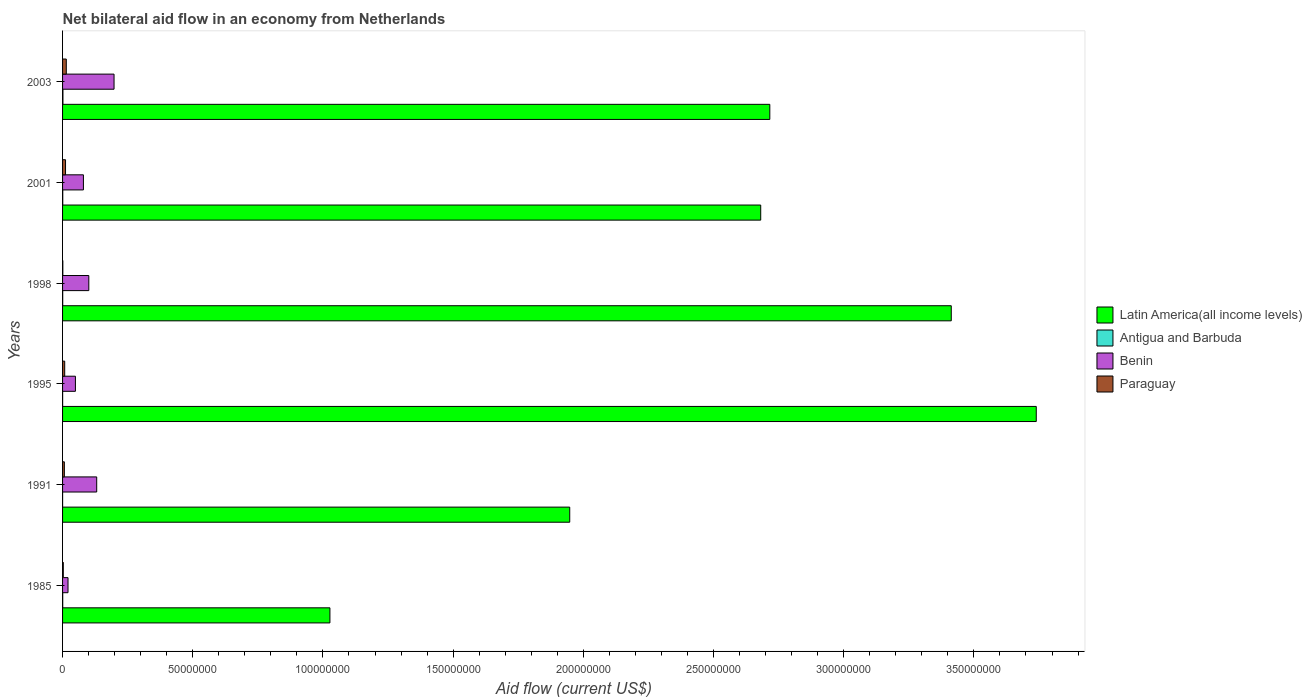How many groups of bars are there?
Offer a terse response. 6. In how many cases, is the number of bars for a given year not equal to the number of legend labels?
Provide a succinct answer. 0. What is the net bilateral aid flow in Antigua and Barbuda in 1991?
Your response must be concise. 10000. Across all years, what is the maximum net bilateral aid flow in Paraguay?
Offer a terse response. 1.43e+06. Across all years, what is the minimum net bilateral aid flow in Paraguay?
Make the answer very short. 1.00e+05. In which year was the net bilateral aid flow in Paraguay maximum?
Provide a succinct answer. 2003. What is the total net bilateral aid flow in Paraguay in the graph?
Ensure brevity in your answer.  4.46e+06. What is the difference between the net bilateral aid flow in Antigua and Barbuda in 1991 and that in 1998?
Provide a succinct answer. -4.00e+04. What is the difference between the net bilateral aid flow in Antigua and Barbuda in 1995 and the net bilateral aid flow in Latin America(all income levels) in 2001?
Keep it short and to the point. -2.68e+08. What is the average net bilateral aid flow in Paraguay per year?
Make the answer very short. 7.43e+05. In the year 2001, what is the difference between the net bilateral aid flow in Paraguay and net bilateral aid flow in Latin America(all income levels)?
Keep it short and to the point. -2.67e+08. In how many years, is the net bilateral aid flow in Paraguay greater than 70000000 US$?
Give a very brief answer. 0. What is the ratio of the net bilateral aid flow in Paraguay in 1995 to that in 2003?
Your answer should be compact. 0.57. What is the difference between the highest and the lowest net bilateral aid flow in Benin?
Your response must be concise. 1.77e+07. In how many years, is the net bilateral aid flow in Antigua and Barbuda greater than the average net bilateral aid flow in Antigua and Barbuda taken over all years?
Offer a very short reply. 3. What does the 4th bar from the top in 1998 represents?
Provide a short and direct response. Latin America(all income levels). What does the 3rd bar from the bottom in 1998 represents?
Provide a succinct answer. Benin. Is it the case that in every year, the sum of the net bilateral aid flow in Benin and net bilateral aid flow in Latin America(all income levels) is greater than the net bilateral aid flow in Paraguay?
Provide a succinct answer. Yes. Are all the bars in the graph horizontal?
Your response must be concise. Yes. How many years are there in the graph?
Provide a succinct answer. 6. Does the graph contain any zero values?
Make the answer very short. No. Does the graph contain grids?
Offer a very short reply. No. Where does the legend appear in the graph?
Your response must be concise. Center right. How many legend labels are there?
Ensure brevity in your answer.  4. How are the legend labels stacked?
Provide a short and direct response. Vertical. What is the title of the graph?
Your response must be concise. Net bilateral aid flow in an economy from Netherlands. Does "Antigua and Barbuda" appear as one of the legend labels in the graph?
Provide a short and direct response. Yes. What is the label or title of the X-axis?
Make the answer very short. Aid flow (current US$). What is the Aid flow (current US$) in Latin America(all income levels) in 1985?
Give a very brief answer. 1.03e+08. What is the Aid flow (current US$) of Benin in 1985?
Keep it short and to the point. 2.09e+06. What is the Aid flow (current US$) of Paraguay in 1985?
Your answer should be compact. 2.80e+05. What is the Aid flow (current US$) in Latin America(all income levels) in 1991?
Your answer should be compact. 1.95e+08. What is the Aid flow (current US$) of Antigua and Barbuda in 1991?
Offer a very short reply. 10000. What is the Aid flow (current US$) in Benin in 1991?
Ensure brevity in your answer.  1.31e+07. What is the Aid flow (current US$) of Paraguay in 1991?
Provide a short and direct response. 6.90e+05. What is the Aid flow (current US$) of Latin America(all income levels) in 1995?
Make the answer very short. 3.74e+08. What is the Aid flow (current US$) in Benin in 1995?
Make the answer very short. 4.94e+06. What is the Aid flow (current US$) in Paraguay in 1995?
Your answer should be compact. 8.20e+05. What is the Aid flow (current US$) of Latin America(all income levels) in 1998?
Make the answer very short. 3.41e+08. What is the Aid flow (current US$) in Benin in 1998?
Make the answer very short. 1.01e+07. What is the Aid flow (current US$) of Paraguay in 1998?
Give a very brief answer. 1.00e+05. What is the Aid flow (current US$) of Latin America(all income levels) in 2001?
Provide a short and direct response. 2.68e+08. What is the Aid flow (current US$) of Antigua and Barbuda in 2001?
Make the answer very short. 7.00e+04. What is the Aid flow (current US$) in Benin in 2001?
Offer a terse response. 8.01e+06. What is the Aid flow (current US$) in Paraguay in 2001?
Make the answer very short. 1.14e+06. What is the Aid flow (current US$) in Latin America(all income levels) in 2003?
Provide a succinct answer. 2.72e+08. What is the Aid flow (current US$) of Antigua and Barbuda in 2003?
Offer a terse response. 1.40e+05. What is the Aid flow (current US$) of Benin in 2003?
Offer a terse response. 1.98e+07. What is the Aid flow (current US$) of Paraguay in 2003?
Offer a terse response. 1.43e+06. Across all years, what is the maximum Aid flow (current US$) of Latin America(all income levels)?
Offer a very short reply. 3.74e+08. Across all years, what is the maximum Aid flow (current US$) of Benin?
Ensure brevity in your answer.  1.98e+07. Across all years, what is the maximum Aid flow (current US$) in Paraguay?
Provide a short and direct response. 1.43e+06. Across all years, what is the minimum Aid flow (current US$) of Latin America(all income levels)?
Offer a terse response. 1.03e+08. Across all years, what is the minimum Aid flow (current US$) in Antigua and Barbuda?
Provide a short and direct response. 10000. Across all years, what is the minimum Aid flow (current US$) in Benin?
Offer a very short reply. 2.09e+06. Across all years, what is the minimum Aid flow (current US$) in Paraguay?
Your answer should be compact. 1.00e+05. What is the total Aid flow (current US$) in Latin America(all income levels) in the graph?
Offer a very short reply. 1.55e+09. What is the total Aid flow (current US$) in Benin in the graph?
Give a very brief answer. 5.80e+07. What is the total Aid flow (current US$) in Paraguay in the graph?
Provide a short and direct response. 4.46e+06. What is the difference between the Aid flow (current US$) of Latin America(all income levels) in 1985 and that in 1991?
Provide a succinct answer. -9.21e+07. What is the difference between the Aid flow (current US$) in Benin in 1985 and that in 1991?
Provide a succinct answer. -1.10e+07. What is the difference between the Aid flow (current US$) in Paraguay in 1985 and that in 1991?
Your response must be concise. -4.10e+05. What is the difference between the Aid flow (current US$) in Latin America(all income levels) in 1985 and that in 1995?
Offer a very short reply. -2.71e+08. What is the difference between the Aid flow (current US$) in Benin in 1985 and that in 1995?
Offer a very short reply. -2.85e+06. What is the difference between the Aid flow (current US$) of Paraguay in 1985 and that in 1995?
Provide a short and direct response. -5.40e+05. What is the difference between the Aid flow (current US$) in Latin America(all income levels) in 1985 and that in 1998?
Keep it short and to the point. -2.39e+08. What is the difference between the Aid flow (current US$) of Antigua and Barbuda in 1985 and that in 1998?
Offer a very short reply. 10000. What is the difference between the Aid flow (current US$) in Benin in 1985 and that in 1998?
Give a very brief answer. -7.99e+06. What is the difference between the Aid flow (current US$) in Latin America(all income levels) in 1985 and that in 2001?
Provide a succinct answer. -1.65e+08. What is the difference between the Aid flow (current US$) in Benin in 1985 and that in 2001?
Your answer should be compact. -5.92e+06. What is the difference between the Aid flow (current US$) in Paraguay in 1985 and that in 2001?
Your answer should be very brief. -8.60e+05. What is the difference between the Aid flow (current US$) of Latin America(all income levels) in 1985 and that in 2003?
Provide a short and direct response. -1.69e+08. What is the difference between the Aid flow (current US$) of Antigua and Barbuda in 1985 and that in 2003?
Your answer should be very brief. -8.00e+04. What is the difference between the Aid flow (current US$) in Benin in 1985 and that in 2003?
Keep it short and to the point. -1.77e+07. What is the difference between the Aid flow (current US$) in Paraguay in 1985 and that in 2003?
Provide a succinct answer. -1.15e+06. What is the difference between the Aid flow (current US$) of Latin America(all income levels) in 1991 and that in 1995?
Offer a very short reply. -1.79e+08. What is the difference between the Aid flow (current US$) in Benin in 1991 and that in 1995?
Your answer should be very brief. 8.17e+06. What is the difference between the Aid flow (current US$) of Latin America(all income levels) in 1991 and that in 1998?
Offer a terse response. -1.47e+08. What is the difference between the Aid flow (current US$) in Benin in 1991 and that in 1998?
Provide a short and direct response. 3.03e+06. What is the difference between the Aid flow (current US$) in Paraguay in 1991 and that in 1998?
Offer a very short reply. 5.90e+05. What is the difference between the Aid flow (current US$) in Latin America(all income levels) in 1991 and that in 2001?
Your answer should be very brief. -7.34e+07. What is the difference between the Aid flow (current US$) in Benin in 1991 and that in 2001?
Make the answer very short. 5.10e+06. What is the difference between the Aid flow (current US$) in Paraguay in 1991 and that in 2001?
Ensure brevity in your answer.  -4.50e+05. What is the difference between the Aid flow (current US$) of Latin America(all income levels) in 1991 and that in 2003?
Your answer should be compact. -7.68e+07. What is the difference between the Aid flow (current US$) in Benin in 1991 and that in 2003?
Offer a terse response. -6.66e+06. What is the difference between the Aid flow (current US$) of Paraguay in 1991 and that in 2003?
Provide a short and direct response. -7.40e+05. What is the difference between the Aid flow (current US$) in Latin America(all income levels) in 1995 and that in 1998?
Ensure brevity in your answer.  3.26e+07. What is the difference between the Aid flow (current US$) in Antigua and Barbuda in 1995 and that in 1998?
Your response must be concise. -3.00e+04. What is the difference between the Aid flow (current US$) in Benin in 1995 and that in 1998?
Keep it short and to the point. -5.14e+06. What is the difference between the Aid flow (current US$) in Paraguay in 1995 and that in 1998?
Your answer should be very brief. 7.20e+05. What is the difference between the Aid flow (current US$) of Latin America(all income levels) in 1995 and that in 2001?
Your answer should be compact. 1.06e+08. What is the difference between the Aid flow (current US$) in Benin in 1995 and that in 2001?
Give a very brief answer. -3.07e+06. What is the difference between the Aid flow (current US$) of Paraguay in 1995 and that in 2001?
Keep it short and to the point. -3.20e+05. What is the difference between the Aid flow (current US$) in Latin America(all income levels) in 1995 and that in 2003?
Your answer should be very brief. 1.02e+08. What is the difference between the Aid flow (current US$) in Antigua and Barbuda in 1995 and that in 2003?
Your response must be concise. -1.20e+05. What is the difference between the Aid flow (current US$) of Benin in 1995 and that in 2003?
Provide a succinct answer. -1.48e+07. What is the difference between the Aid flow (current US$) in Paraguay in 1995 and that in 2003?
Ensure brevity in your answer.  -6.10e+05. What is the difference between the Aid flow (current US$) of Latin America(all income levels) in 1998 and that in 2001?
Ensure brevity in your answer.  7.32e+07. What is the difference between the Aid flow (current US$) in Antigua and Barbuda in 1998 and that in 2001?
Your answer should be very brief. -2.00e+04. What is the difference between the Aid flow (current US$) in Benin in 1998 and that in 2001?
Offer a terse response. 2.07e+06. What is the difference between the Aid flow (current US$) of Paraguay in 1998 and that in 2001?
Keep it short and to the point. -1.04e+06. What is the difference between the Aid flow (current US$) in Latin America(all income levels) in 1998 and that in 2003?
Offer a very short reply. 6.97e+07. What is the difference between the Aid flow (current US$) in Benin in 1998 and that in 2003?
Offer a very short reply. -9.69e+06. What is the difference between the Aid flow (current US$) in Paraguay in 1998 and that in 2003?
Give a very brief answer. -1.33e+06. What is the difference between the Aid flow (current US$) of Latin America(all income levels) in 2001 and that in 2003?
Give a very brief answer. -3.49e+06. What is the difference between the Aid flow (current US$) of Antigua and Barbuda in 2001 and that in 2003?
Give a very brief answer. -7.00e+04. What is the difference between the Aid flow (current US$) of Benin in 2001 and that in 2003?
Ensure brevity in your answer.  -1.18e+07. What is the difference between the Aid flow (current US$) of Paraguay in 2001 and that in 2003?
Keep it short and to the point. -2.90e+05. What is the difference between the Aid flow (current US$) of Latin America(all income levels) in 1985 and the Aid flow (current US$) of Antigua and Barbuda in 1991?
Offer a very short reply. 1.03e+08. What is the difference between the Aid flow (current US$) in Latin America(all income levels) in 1985 and the Aid flow (current US$) in Benin in 1991?
Your response must be concise. 8.96e+07. What is the difference between the Aid flow (current US$) of Latin America(all income levels) in 1985 and the Aid flow (current US$) of Paraguay in 1991?
Your answer should be compact. 1.02e+08. What is the difference between the Aid flow (current US$) in Antigua and Barbuda in 1985 and the Aid flow (current US$) in Benin in 1991?
Give a very brief answer. -1.30e+07. What is the difference between the Aid flow (current US$) in Antigua and Barbuda in 1985 and the Aid flow (current US$) in Paraguay in 1991?
Give a very brief answer. -6.30e+05. What is the difference between the Aid flow (current US$) of Benin in 1985 and the Aid flow (current US$) of Paraguay in 1991?
Provide a succinct answer. 1.40e+06. What is the difference between the Aid flow (current US$) in Latin America(all income levels) in 1985 and the Aid flow (current US$) in Antigua and Barbuda in 1995?
Your response must be concise. 1.03e+08. What is the difference between the Aid flow (current US$) in Latin America(all income levels) in 1985 and the Aid flow (current US$) in Benin in 1995?
Offer a terse response. 9.77e+07. What is the difference between the Aid flow (current US$) in Latin America(all income levels) in 1985 and the Aid flow (current US$) in Paraguay in 1995?
Keep it short and to the point. 1.02e+08. What is the difference between the Aid flow (current US$) of Antigua and Barbuda in 1985 and the Aid flow (current US$) of Benin in 1995?
Give a very brief answer. -4.88e+06. What is the difference between the Aid flow (current US$) in Antigua and Barbuda in 1985 and the Aid flow (current US$) in Paraguay in 1995?
Offer a terse response. -7.60e+05. What is the difference between the Aid flow (current US$) of Benin in 1985 and the Aid flow (current US$) of Paraguay in 1995?
Your answer should be very brief. 1.27e+06. What is the difference between the Aid flow (current US$) of Latin America(all income levels) in 1985 and the Aid flow (current US$) of Antigua and Barbuda in 1998?
Keep it short and to the point. 1.03e+08. What is the difference between the Aid flow (current US$) in Latin America(all income levels) in 1985 and the Aid flow (current US$) in Benin in 1998?
Give a very brief answer. 9.26e+07. What is the difference between the Aid flow (current US$) of Latin America(all income levels) in 1985 and the Aid flow (current US$) of Paraguay in 1998?
Your answer should be compact. 1.03e+08. What is the difference between the Aid flow (current US$) of Antigua and Barbuda in 1985 and the Aid flow (current US$) of Benin in 1998?
Provide a succinct answer. -1.00e+07. What is the difference between the Aid flow (current US$) in Benin in 1985 and the Aid flow (current US$) in Paraguay in 1998?
Provide a succinct answer. 1.99e+06. What is the difference between the Aid flow (current US$) in Latin America(all income levels) in 1985 and the Aid flow (current US$) in Antigua and Barbuda in 2001?
Make the answer very short. 1.03e+08. What is the difference between the Aid flow (current US$) in Latin America(all income levels) in 1985 and the Aid flow (current US$) in Benin in 2001?
Ensure brevity in your answer.  9.47e+07. What is the difference between the Aid flow (current US$) in Latin America(all income levels) in 1985 and the Aid flow (current US$) in Paraguay in 2001?
Give a very brief answer. 1.02e+08. What is the difference between the Aid flow (current US$) in Antigua and Barbuda in 1985 and the Aid flow (current US$) in Benin in 2001?
Your answer should be compact. -7.95e+06. What is the difference between the Aid flow (current US$) in Antigua and Barbuda in 1985 and the Aid flow (current US$) in Paraguay in 2001?
Offer a very short reply. -1.08e+06. What is the difference between the Aid flow (current US$) in Benin in 1985 and the Aid flow (current US$) in Paraguay in 2001?
Keep it short and to the point. 9.50e+05. What is the difference between the Aid flow (current US$) of Latin America(all income levels) in 1985 and the Aid flow (current US$) of Antigua and Barbuda in 2003?
Ensure brevity in your answer.  1.03e+08. What is the difference between the Aid flow (current US$) of Latin America(all income levels) in 1985 and the Aid flow (current US$) of Benin in 2003?
Offer a very short reply. 8.29e+07. What is the difference between the Aid flow (current US$) in Latin America(all income levels) in 1985 and the Aid flow (current US$) in Paraguay in 2003?
Your answer should be compact. 1.01e+08. What is the difference between the Aid flow (current US$) in Antigua and Barbuda in 1985 and the Aid flow (current US$) in Benin in 2003?
Offer a terse response. -1.97e+07. What is the difference between the Aid flow (current US$) of Antigua and Barbuda in 1985 and the Aid flow (current US$) of Paraguay in 2003?
Your answer should be compact. -1.37e+06. What is the difference between the Aid flow (current US$) in Benin in 1985 and the Aid flow (current US$) in Paraguay in 2003?
Offer a very short reply. 6.60e+05. What is the difference between the Aid flow (current US$) in Latin America(all income levels) in 1991 and the Aid flow (current US$) in Antigua and Barbuda in 1995?
Keep it short and to the point. 1.95e+08. What is the difference between the Aid flow (current US$) of Latin America(all income levels) in 1991 and the Aid flow (current US$) of Benin in 1995?
Your answer should be very brief. 1.90e+08. What is the difference between the Aid flow (current US$) in Latin America(all income levels) in 1991 and the Aid flow (current US$) in Paraguay in 1995?
Your response must be concise. 1.94e+08. What is the difference between the Aid flow (current US$) of Antigua and Barbuda in 1991 and the Aid flow (current US$) of Benin in 1995?
Your answer should be very brief. -4.93e+06. What is the difference between the Aid flow (current US$) of Antigua and Barbuda in 1991 and the Aid flow (current US$) of Paraguay in 1995?
Your response must be concise. -8.10e+05. What is the difference between the Aid flow (current US$) in Benin in 1991 and the Aid flow (current US$) in Paraguay in 1995?
Your answer should be very brief. 1.23e+07. What is the difference between the Aid flow (current US$) in Latin America(all income levels) in 1991 and the Aid flow (current US$) in Antigua and Barbuda in 1998?
Your answer should be very brief. 1.95e+08. What is the difference between the Aid flow (current US$) of Latin America(all income levels) in 1991 and the Aid flow (current US$) of Benin in 1998?
Give a very brief answer. 1.85e+08. What is the difference between the Aid flow (current US$) of Latin America(all income levels) in 1991 and the Aid flow (current US$) of Paraguay in 1998?
Your answer should be compact. 1.95e+08. What is the difference between the Aid flow (current US$) in Antigua and Barbuda in 1991 and the Aid flow (current US$) in Benin in 1998?
Keep it short and to the point. -1.01e+07. What is the difference between the Aid flow (current US$) in Benin in 1991 and the Aid flow (current US$) in Paraguay in 1998?
Make the answer very short. 1.30e+07. What is the difference between the Aid flow (current US$) of Latin America(all income levels) in 1991 and the Aid flow (current US$) of Antigua and Barbuda in 2001?
Ensure brevity in your answer.  1.95e+08. What is the difference between the Aid flow (current US$) in Latin America(all income levels) in 1991 and the Aid flow (current US$) in Benin in 2001?
Ensure brevity in your answer.  1.87e+08. What is the difference between the Aid flow (current US$) in Latin America(all income levels) in 1991 and the Aid flow (current US$) in Paraguay in 2001?
Your response must be concise. 1.94e+08. What is the difference between the Aid flow (current US$) in Antigua and Barbuda in 1991 and the Aid flow (current US$) in Benin in 2001?
Give a very brief answer. -8.00e+06. What is the difference between the Aid flow (current US$) of Antigua and Barbuda in 1991 and the Aid flow (current US$) of Paraguay in 2001?
Give a very brief answer. -1.13e+06. What is the difference between the Aid flow (current US$) of Benin in 1991 and the Aid flow (current US$) of Paraguay in 2001?
Keep it short and to the point. 1.20e+07. What is the difference between the Aid flow (current US$) in Latin America(all income levels) in 1991 and the Aid flow (current US$) in Antigua and Barbuda in 2003?
Make the answer very short. 1.95e+08. What is the difference between the Aid flow (current US$) of Latin America(all income levels) in 1991 and the Aid flow (current US$) of Benin in 2003?
Give a very brief answer. 1.75e+08. What is the difference between the Aid flow (current US$) of Latin America(all income levels) in 1991 and the Aid flow (current US$) of Paraguay in 2003?
Your answer should be very brief. 1.93e+08. What is the difference between the Aid flow (current US$) in Antigua and Barbuda in 1991 and the Aid flow (current US$) in Benin in 2003?
Your response must be concise. -1.98e+07. What is the difference between the Aid flow (current US$) of Antigua and Barbuda in 1991 and the Aid flow (current US$) of Paraguay in 2003?
Your response must be concise. -1.42e+06. What is the difference between the Aid flow (current US$) in Benin in 1991 and the Aid flow (current US$) in Paraguay in 2003?
Keep it short and to the point. 1.17e+07. What is the difference between the Aid flow (current US$) in Latin America(all income levels) in 1995 and the Aid flow (current US$) in Antigua and Barbuda in 1998?
Offer a terse response. 3.74e+08. What is the difference between the Aid flow (current US$) in Latin America(all income levels) in 1995 and the Aid flow (current US$) in Benin in 1998?
Your response must be concise. 3.64e+08. What is the difference between the Aid flow (current US$) in Latin America(all income levels) in 1995 and the Aid flow (current US$) in Paraguay in 1998?
Provide a succinct answer. 3.74e+08. What is the difference between the Aid flow (current US$) of Antigua and Barbuda in 1995 and the Aid flow (current US$) of Benin in 1998?
Your response must be concise. -1.01e+07. What is the difference between the Aid flow (current US$) in Antigua and Barbuda in 1995 and the Aid flow (current US$) in Paraguay in 1998?
Your response must be concise. -8.00e+04. What is the difference between the Aid flow (current US$) in Benin in 1995 and the Aid flow (current US$) in Paraguay in 1998?
Offer a terse response. 4.84e+06. What is the difference between the Aid flow (current US$) in Latin America(all income levels) in 1995 and the Aid flow (current US$) in Antigua and Barbuda in 2001?
Give a very brief answer. 3.74e+08. What is the difference between the Aid flow (current US$) in Latin America(all income levels) in 1995 and the Aid flow (current US$) in Benin in 2001?
Give a very brief answer. 3.66e+08. What is the difference between the Aid flow (current US$) of Latin America(all income levels) in 1995 and the Aid flow (current US$) of Paraguay in 2001?
Provide a succinct answer. 3.73e+08. What is the difference between the Aid flow (current US$) in Antigua and Barbuda in 1995 and the Aid flow (current US$) in Benin in 2001?
Your answer should be very brief. -7.99e+06. What is the difference between the Aid flow (current US$) in Antigua and Barbuda in 1995 and the Aid flow (current US$) in Paraguay in 2001?
Your response must be concise. -1.12e+06. What is the difference between the Aid flow (current US$) of Benin in 1995 and the Aid flow (current US$) of Paraguay in 2001?
Provide a short and direct response. 3.80e+06. What is the difference between the Aid flow (current US$) in Latin America(all income levels) in 1995 and the Aid flow (current US$) in Antigua and Barbuda in 2003?
Provide a succinct answer. 3.74e+08. What is the difference between the Aid flow (current US$) in Latin America(all income levels) in 1995 and the Aid flow (current US$) in Benin in 2003?
Provide a short and direct response. 3.54e+08. What is the difference between the Aid flow (current US$) of Latin America(all income levels) in 1995 and the Aid flow (current US$) of Paraguay in 2003?
Offer a very short reply. 3.73e+08. What is the difference between the Aid flow (current US$) of Antigua and Barbuda in 1995 and the Aid flow (current US$) of Benin in 2003?
Provide a succinct answer. -1.98e+07. What is the difference between the Aid flow (current US$) of Antigua and Barbuda in 1995 and the Aid flow (current US$) of Paraguay in 2003?
Offer a terse response. -1.41e+06. What is the difference between the Aid flow (current US$) in Benin in 1995 and the Aid flow (current US$) in Paraguay in 2003?
Ensure brevity in your answer.  3.51e+06. What is the difference between the Aid flow (current US$) of Latin America(all income levels) in 1998 and the Aid flow (current US$) of Antigua and Barbuda in 2001?
Your answer should be very brief. 3.41e+08. What is the difference between the Aid flow (current US$) of Latin America(all income levels) in 1998 and the Aid flow (current US$) of Benin in 2001?
Provide a succinct answer. 3.33e+08. What is the difference between the Aid flow (current US$) in Latin America(all income levels) in 1998 and the Aid flow (current US$) in Paraguay in 2001?
Your answer should be compact. 3.40e+08. What is the difference between the Aid flow (current US$) of Antigua and Barbuda in 1998 and the Aid flow (current US$) of Benin in 2001?
Your response must be concise. -7.96e+06. What is the difference between the Aid flow (current US$) in Antigua and Barbuda in 1998 and the Aid flow (current US$) in Paraguay in 2001?
Provide a short and direct response. -1.09e+06. What is the difference between the Aid flow (current US$) of Benin in 1998 and the Aid flow (current US$) of Paraguay in 2001?
Your answer should be compact. 8.94e+06. What is the difference between the Aid flow (current US$) in Latin America(all income levels) in 1998 and the Aid flow (current US$) in Antigua and Barbuda in 2003?
Your response must be concise. 3.41e+08. What is the difference between the Aid flow (current US$) in Latin America(all income levels) in 1998 and the Aid flow (current US$) in Benin in 2003?
Your answer should be compact. 3.22e+08. What is the difference between the Aid flow (current US$) of Latin America(all income levels) in 1998 and the Aid flow (current US$) of Paraguay in 2003?
Give a very brief answer. 3.40e+08. What is the difference between the Aid flow (current US$) of Antigua and Barbuda in 1998 and the Aid flow (current US$) of Benin in 2003?
Offer a terse response. -1.97e+07. What is the difference between the Aid flow (current US$) of Antigua and Barbuda in 1998 and the Aid flow (current US$) of Paraguay in 2003?
Make the answer very short. -1.38e+06. What is the difference between the Aid flow (current US$) in Benin in 1998 and the Aid flow (current US$) in Paraguay in 2003?
Your answer should be very brief. 8.65e+06. What is the difference between the Aid flow (current US$) of Latin America(all income levels) in 2001 and the Aid flow (current US$) of Antigua and Barbuda in 2003?
Provide a succinct answer. 2.68e+08. What is the difference between the Aid flow (current US$) of Latin America(all income levels) in 2001 and the Aid flow (current US$) of Benin in 2003?
Your response must be concise. 2.48e+08. What is the difference between the Aid flow (current US$) in Latin America(all income levels) in 2001 and the Aid flow (current US$) in Paraguay in 2003?
Keep it short and to the point. 2.67e+08. What is the difference between the Aid flow (current US$) of Antigua and Barbuda in 2001 and the Aid flow (current US$) of Benin in 2003?
Keep it short and to the point. -1.97e+07. What is the difference between the Aid flow (current US$) of Antigua and Barbuda in 2001 and the Aid flow (current US$) of Paraguay in 2003?
Your response must be concise. -1.36e+06. What is the difference between the Aid flow (current US$) of Benin in 2001 and the Aid flow (current US$) of Paraguay in 2003?
Make the answer very short. 6.58e+06. What is the average Aid flow (current US$) in Latin America(all income levels) per year?
Your answer should be very brief. 2.59e+08. What is the average Aid flow (current US$) of Antigua and Barbuda per year?
Make the answer very short. 5.83e+04. What is the average Aid flow (current US$) in Benin per year?
Offer a very short reply. 9.67e+06. What is the average Aid flow (current US$) in Paraguay per year?
Provide a succinct answer. 7.43e+05. In the year 1985, what is the difference between the Aid flow (current US$) in Latin America(all income levels) and Aid flow (current US$) in Antigua and Barbuda?
Your answer should be very brief. 1.03e+08. In the year 1985, what is the difference between the Aid flow (current US$) in Latin America(all income levels) and Aid flow (current US$) in Benin?
Give a very brief answer. 1.01e+08. In the year 1985, what is the difference between the Aid flow (current US$) of Latin America(all income levels) and Aid flow (current US$) of Paraguay?
Ensure brevity in your answer.  1.02e+08. In the year 1985, what is the difference between the Aid flow (current US$) in Antigua and Barbuda and Aid flow (current US$) in Benin?
Provide a short and direct response. -2.03e+06. In the year 1985, what is the difference between the Aid flow (current US$) in Antigua and Barbuda and Aid flow (current US$) in Paraguay?
Offer a very short reply. -2.20e+05. In the year 1985, what is the difference between the Aid flow (current US$) in Benin and Aid flow (current US$) in Paraguay?
Your answer should be compact. 1.81e+06. In the year 1991, what is the difference between the Aid flow (current US$) in Latin America(all income levels) and Aid flow (current US$) in Antigua and Barbuda?
Your answer should be compact. 1.95e+08. In the year 1991, what is the difference between the Aid flow (current US$) of Latin America(all income levels) and Aid flow (current US$) of Benin?
Your response must be concise. 1.82e+08. In the year 1991, what is the difference between the Aid flow (current US$) of Latin America(all income levels) and Aid flow (current US$) of Paraguay?
Provide a short and direct response. 1.94e+08. In the year 1991, what is the difference between the Aid flow (current US$) of Antigua and Barbuda and Aid flow (current US$) of Benin?
Ensure brevity in your answer.  -1.31e+07. In the year 1991, what is the difference between the Aid flow (current US$) in Antigua and Barbuda and Aid flow (current US$) in Paraguay?
Ensure brevity in your answer.  -6.80e+05. In the year 1991, what is the difference between the Aid flow (current US$) of Benin and Aid flow (current US$) of Paraguay?
Keep it short and to the point. 1.24e+07. In the year 1995, what is the difference between the Aid flow (current US$) in Latin America(all income levels) and Aid flow (current US$) in Antigua and Barbuda?
Provide a succinct answer. 3.74e+08. In the year 1995, what is the difference between the Aid flow (current US$) in Latin America(all income levels) and Aid flow (current US$) in Benin?
Your answer should be very brief. 3.69e+08. In the year 1995, what is the difference between the Aid flow (current US$) in Latin America(all income levels) and Aid flow (current US$) in Paraguay?
Provide a succinct answer. 3.73e+08. In the year 1995, what is the difference between the Aid flow (current US$) of Antigua and Barbuda and Aid flow (current US$) of Benin?
Offer a very short reply. -4.92e+06. In the year 1995, what is the difference between the Aid flow (current US$) in Antigua and Barbuda and Aid flow (current US$) in Paraguay?
Provide a short and direct response. -8.00e+05. In the year 1995, what is the difference between the Aid flow (current US$) in Benin and Aid flow (current US$) in Paraguay?
Provide a succinct answer. 4.12e+06. In the year 1998, what is the difference between the Aid flow (current US$) of Latin America(all income levels) and Aid flow (current US$) of Antigua and Barbuda?
Provide a short and direct response. 3.41e+08. In the year 1998, what is the difference between the Aid flow (current US$) in Latin America(all income levels) and Aid flow (current US$) in Benin?
Your response must be concise. 3.31e+08. In the year 1998, what is the difference between the Aid flow (current US$) in Latin America(all income levels) and Aid flow (current US$) in Paraguay?
Offer a terse response. 3.41e+08. In the year 1998, what is the difference between the Aid flow (current US$) in Antigua and Barbuda and Aid flow (current US$) in Benin?
Ensure brevity in your answer.  -1.00e+07. In the year 1998, what is the difference between the Aid flow (current US$) of Benin and Aid flow (current US$) of Paraguay?
Ensure brevity in your answer.  9.98e+06. In the year 2001, what is the difference between the Aid flow (current US$) in Latin America(all income levels) and Aid flow (current US$) in Antigua and Barbuda?
Provide a short and direct response. 2.68e+08. In the year 2001, what is the difference between the Aid flow (current US$) of Latin America(all income levels) and Aid flow (current US$) of Benin?
Provide a short and direct response. 2.60e+08. In the year 2001, what is the difference between the Aid flow (current US$) in Latin America(all income levels) and Aid flow (current US$) in Paraguay?
Offer a terse response. 2.67e+08. In the year 2001, what is the difference between the Aid flow (current US$) in Antigua and Barbuda and Aid flow (current US$) in Benin?
Your answer should be compact. -7.94e+06. In the year 2001, what is the difference between the Aid flow (current US$) in Antigua and Barbuda and Aid flow (current US$) in Paraguay?
Your response must be concise. -1.07e+06. In the year 2001, what is the difference between the Aid flow (current US$) of Benin and Aid flow (current US$) of Paraguay?
Your answer should be compact. 6.87e+06. In the year 2003, what is the difference between the Aid flow (current US$) in Latin America(all income levels) and Aid flow (current US$) in Antigua and Barbuda?
Your answer should be compact. 2.71e+08. In the year 2003, what is the difference between the Aid flow (current US$) of Latin America(all income levels) and Aid flow (current US$) of Benin?
Give a very brief answer. 2.52e+08. In the year 2003, what is the difference between the Aid flow (current US$) in Latin America(all income levels) and Aid flow (current US$) in Paraguay?
Keep it short and to the point. 2.70e+08. In the year 2003, what is the difference between the Aid flow (current US$) of Antigua and Barbuda and Aid flow (current US$) of Benin?
Provide a succinct answer. -1.96e+07. In the year 2003, what is the difference between the Aid flow (current US$) of Antigua and Barbuda and Aid flow (current US$) of Paraguay?
Provide a succinct answer. -1.29e+06. In the year 2003, what is the difference between the Aid flow (current US$) in Benin and Aid flow (current US$) in Paraguay?
Your answer should be compact. 1.83e+07. What is the ratio of the Aid flow (current US$) of Latin America(all income levels) in 1985 to that in 1991?
Offer a terse response. 0.53. What is the ratio of the Aid flow (current US$) of Antigua and Barbuda in 1985 to that in 1991?
Your answer should be very brief. 6. What is the ratio of the Aid flow (current US$) in Benin in 1985 to that in 1991?
Give a very brief answer. 0.16. What is the ratio of the Aid flow (current US$) in Paraguay in 1985 to that in 1991?
Make the answer very short. 0.41. What is the ratio of the Aid flow (current US$) of Latin America(all income levels) in 1985 to that in 1995?
Ensure brevity in your answer.  0.27. What is the ratio of the Aid flow (current US$) in Benin in 1985 to that in 1995?
Provide a short and direct response. 0.42. What is the ratio of the Aid flow (current US$) of Paraguay in 1985 to that in 1995?
Offer a very short reply. 0.34. What is the ratio of the Aid flow (current US$) in Latin America(all income levels) in 1985 to that in 1998?
Your answer should be compact. 0.3. What is the ratio of the Aid flow (current US$) in Antigua and Barbuda in 1985 to that in 1998?
Keep it short and to the point. 1.2. What is the ratio of the Aid flow (current US$) of Benin in 1985 to that in 1998?
Your answer should be very brief. 0.21. What is the ratio of the Aid flow (current US$) of Latin America(all income levels) in 1985 to that in 2001?
Provide a short and direct response. 0.38. What is the ratio of the Aid flow (current US$) of Antigua and Barbuda in 1985 to that in 2001?
Your response must be concise. 0.86. What is the ratio of the Aid flow (current US$) in Benin in 1985 to that in 2001?
Your response must be concise. 0.26. What is the ratio of the Aid flow (current US$) in Paraguay in 1985 to that in 2001?
Your answer should be very brief. 0.25. What is the ratio of the Aid flow (current US$) in Latin America(all income levels) in 1985 to that in 2003?
Ensure brevity in your answer.  0.38. What is the ratio of the Aid flow (current US$) of Antigua and Barbuda in 1985 to that in 2003?
Keep it short and to the point. 0.43. What is the ratio of the Aid flow (current US$) in Benin in 1985 to that in 2003?
Give a very brief answer. 0.11. What is the ratio of the Aid flow (current US$) of Paraguay in 1985 to that in 2003?
Provide a short and direct response. 0.2. What is the ratio of the Aid flow (current US$) in Latin America(all income levels) in 1991 to that in 1995?
Your answer should be very brief. 0.52. What is the ratio of the Aid flow (current US$) in Antigua and Barbuda in 1991 to that in 1995?
Give a very brief answer. 0.5. What is the ratio of the Aid flow (current US$) of Benin in 1991 to that in 1995?
Your response must be concise. 2.65. What is the ratio of the Aid flow (current US$) in Paraguay in 1991 to that in 1995?
Provide a succinct answer. 0.84. What is the ratio of the Aid flow (current US$) of Latin America(all income levels) in 1991 to that in 1998?
Your answer should be compact. 0.57. What is the ratio of the Aid flow (current US$) in Antigua and Barbuda in 1991 to that in 1998?
Offer a terse response. 0.2. What is the ratio of the Aid flow (current US$) of Benin in 1991 to that in 1998?
Provide a short and direct response. 1.3. What is the ratio of the Aid flow (current US$) of Paraguay in 1991 to that in 1998?
Give a very brief answer. 6.9. What is the ratio of the Aid flow (current US$) of Latin America(all income levels) in 1991 to that in 2001?
Keep it short and to the point. 0.73. What is the ratio of the Aid flow (current US$) in Antigua and Barbuda in 1991 to that in 2001?
Make the answer very short. 0.14. What is the ratio of the Aid flow (current US$) in Benin in 1991 to that in 2001?
Give a very brief answer. 1.64. What is the ratio of the Aid flow (current US$) in Paraguay in 1991 to that in 2001?
Your answer should be very brief. 0.61. What is the ratio of the Aid flow (current US$) in Latin America(all income levels) in 1991 to that in 2003?
Provide a succinct answer. 0.72. What is the ratio of the Aid flow (current US$) of Antigua and Barbuda in 1991 to that in 2003?
Give a very brief answer. 0.07. What is the ratio of the Aid flow (current US$) in Benin in 1991 to that in 2003?
Make the answer very short. 0.66. What is the ratio of the Aid flow (current US$) of Paraguay in 1991 to that in 2003?
Your response must be concise. 0.48. What is the ratio of the Aid flow (current US$) in Latin America(all income levels) in 1995 to that in 1998?
Offer a very short reply. 1.1. What is the ratio of the Aid flow (current US$) of Benin in 1995 to that in 1998?
Your answer should be very brief. 0.49. What is the ratio of the Aid flow (current US$) of Latin America(all income levels) in 1995 to that in 2001?
Keep it short and to the point. 1.39. What is the ratio of the Aid flow (current US$) in Antigua and Barbuda in 1995 to that in 2001?
Provide a short and direct response. 0.29. What is the ratio of the Aid flow (current US$) of Benin in 1995 to that in 2001?
Offer a very short reply. 0.62. What is the ratio of the Aid flow (current US$) of Paraguay in 1995 to that in 2001?
Your response must be concise. 0.72. What is the ratio of the Aid flow (current US$) of Latin America(all income levels) in 1995 to that in 2003?
Your answer should be very brief. 1.38. What is the ratio of the Aid flow (current US$) in Antigua and Barbuda in 1995 to that in 2003?
Your answer should be compact. 0.14. What is the ratio of the Aid flow (current US$) of Benin in 1995 to that in 2003?
Ensure brevity in your answer.  0.25. What is the ratio of the Aid flow (current US$) of Paraguay in 1995 to that in 2003?
Provide a succinct answer. 0.57. What is the ratio of the Aid flow (current US$) in Latin America(all income levels) in 1998 to that in 2001?
Give a very brief answer. 1.27. What is the ratio of the Aid flow (current US$) of Antigua and Barbuda in 1998 to that in 2001?
Give a very brief answer. 0.71. What is the ratio of the Aid flow (current US$) of Benin in 1998 to that in 2001?
Make the answer very short. 1.26. What is the ratio of the Aid flow (current US$) of Paraguay in 1998 to that in 2001?
Keep it short and to the point. 0.09. What is the ratio of the Aid flow (current US$) in Latin America(all income levels) in 1998 to that in 2003?
Your answer should be compact. 1.26. What is the ratio of the Aid flow (current US$) of Antigua and Barbuda in 1998 to that in 2003?
Give a very brief answer. 0.36. What is the ratio of the Aid flow (current US$) in Benin in 1998 to that in 2003?
Offer a terse response. 0.51. What is the ratio of the Aid flow (current US$) of Paraguay in 1998 to that in 2003?
Offer a terse response. 0.07. What is the ratio of the Aid flow (current US$) in Latin America(all income levels) in 2001 to that in 2003?
Give a very brief answer. 0.99. What is the ratio of the Aid flow (current US$) in Antigua and Barbuda in 2001 to that in 2003?
Make the answer very short. 0.5. What is the ratio of the Aid flow (current US$) of Benin in 2001 to that in 2003?
Your answer should be very brief. 0.41. What is the ratio of the Aid flow (current US$) in Paraguay in 2001 to that in 2003?
Provide a succinct answer. 0.8. What is the difference between the highest and the second highest Aid flow (current US$) of Latin America(all income levels)?
Keep it short and to the point. 3.26e+07. What is the difference between the highest and the second highest Aid flow (current US$) of Antigua and Barbuda?
Make the answer very short. 7.00e+04. What is the difference between the highest and the second highest Aid flow (current US$) in Benin?
Keep it short and to the point. 6.66e+06. What is the difference between the highest and the second highest Aid flow (current US$) of Paraguay?
Offer a very short reply. 2.90e+05. What is the difference between the highest and the lowest Aid flow (current US$) in Latin America(all income levels)?
Provide a succinct answer. 2.71e+08. What is the difference between the highest and the lowest Aid flow (current US$) of Benin?
Ensure brevity in your answer.  1.77e+07. What is the difference between the highest and the lowest Aid flow (current US$) of Paraguay?
Your answer should be very brief. 1.33e+06. 